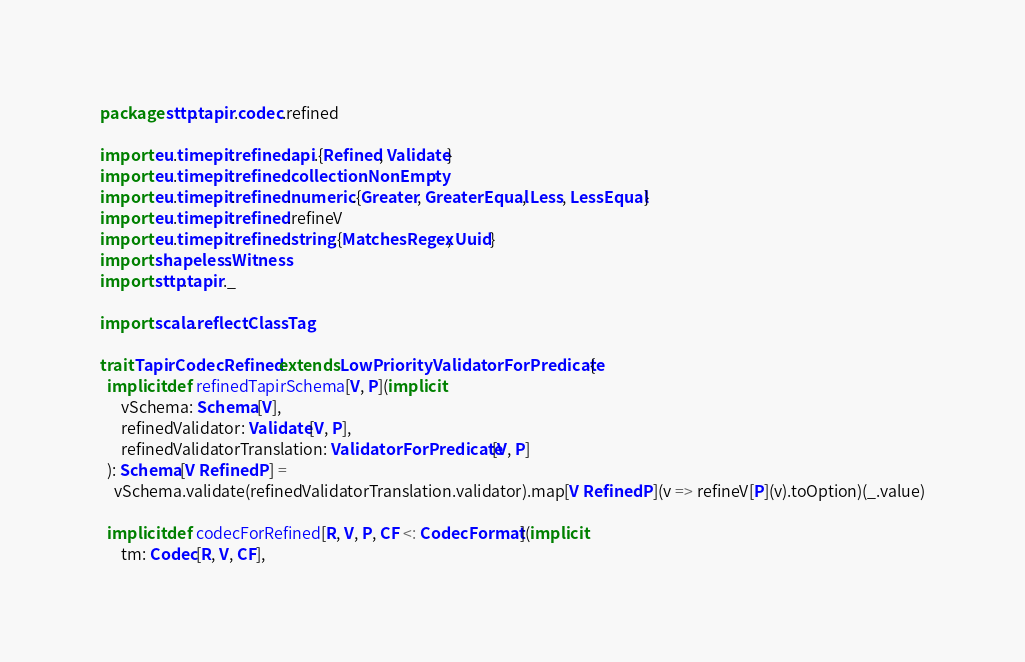Convert code to text. <code><loc_0><loc_0><loc_500><loc_500><_Scala_>package sttp.tapir.codec.refined

import eu.timepit.refined.api.{Refined, Validate}
import eu.timepit.refined.collection.NonEmpty
import eu.timepit.refined.numeric.{Greater, GreaterEqual, Less, LessEqual}
import eu.timepit.refined.refineV
import eu.timepit.refined.string.{MatchesRegex, Uuid}
import shapeless.Witness
import sttp.tapir._

import scala.reflect.ClassTag

trait TapirCodecRefined extends LowPriorityValidatorForPredicate {
  implicit def refinedTapirSchema[V, P](implicit
      vSchema: Schema[V],
      refinedValidator: Validate[V, P],
      refinedValidatorTranslation: ValidatorForPredicate[V, P]
  ): Schema[V Refined P] =
    vSchema.validate(refinedValidatorTranslation.validator).map[V Refined P](v => refineV[P](v).toOption)(_.value)

  implicit def codecForRefined[R, V, P, CF <: CodecFormat](implicit
      tm: Codec[R, V, CF],</code> 